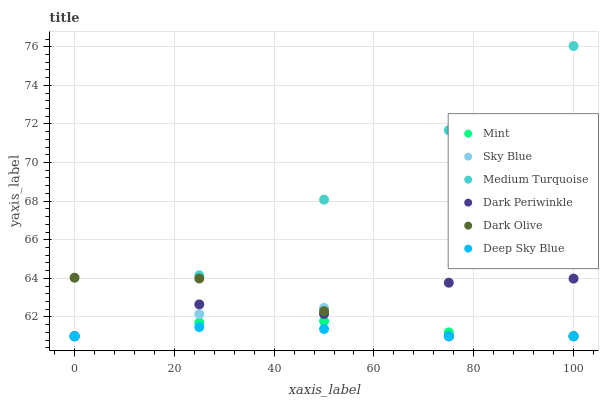Does Deep Sky Blue have the minimum area under the curve?
Answer yes or no. Yes. Does Medium Turquoise have the maximum area under the curve?
Answer yes or no. Yes. Does Dark Olive have the minimum area under the curve?
Answer yes or no. No. Does Dark Olive have the maximum area under the curve?
Answer yes or no. No. Is Deep Sky Blue the smoothest?
Answer yes or no. Yes. Is Dark Periwinkle the roughest?
Answer yes or no. Yes. Is Dark Olive the smoothest?
Answer yes or no. No. Is Dark Olive the roughest?
Answer yes or no. No. Does Deep Sky Blue have the lowest value?
Answer yes or no. Yes. Does Medium Turquoise have the highest value?
Answer yes or no. Yes. Does Dark Olive have the highest value?
Answer yes or no. No. Does Medium Turquoise intersect Dark Olive?
Answer yes or no. Yes. Is Medium Turquoise less than Dark Olive?
Answer yes or no. No. Is Medium Turquoise greater than Dark Olive?
Answer yes or no. No. 